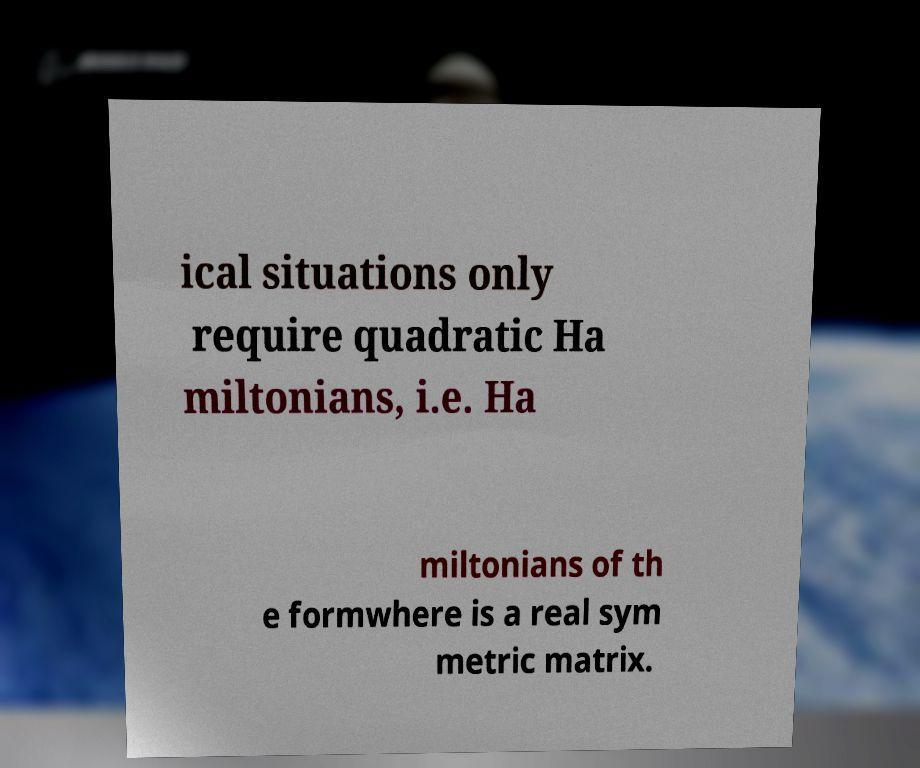Can you accurately transcribe the text from the provided image for me? ical situations only require quadratic Ha miltonians, i.e. Ha miltonians of th e formwhere is a real sym metric matrix. 